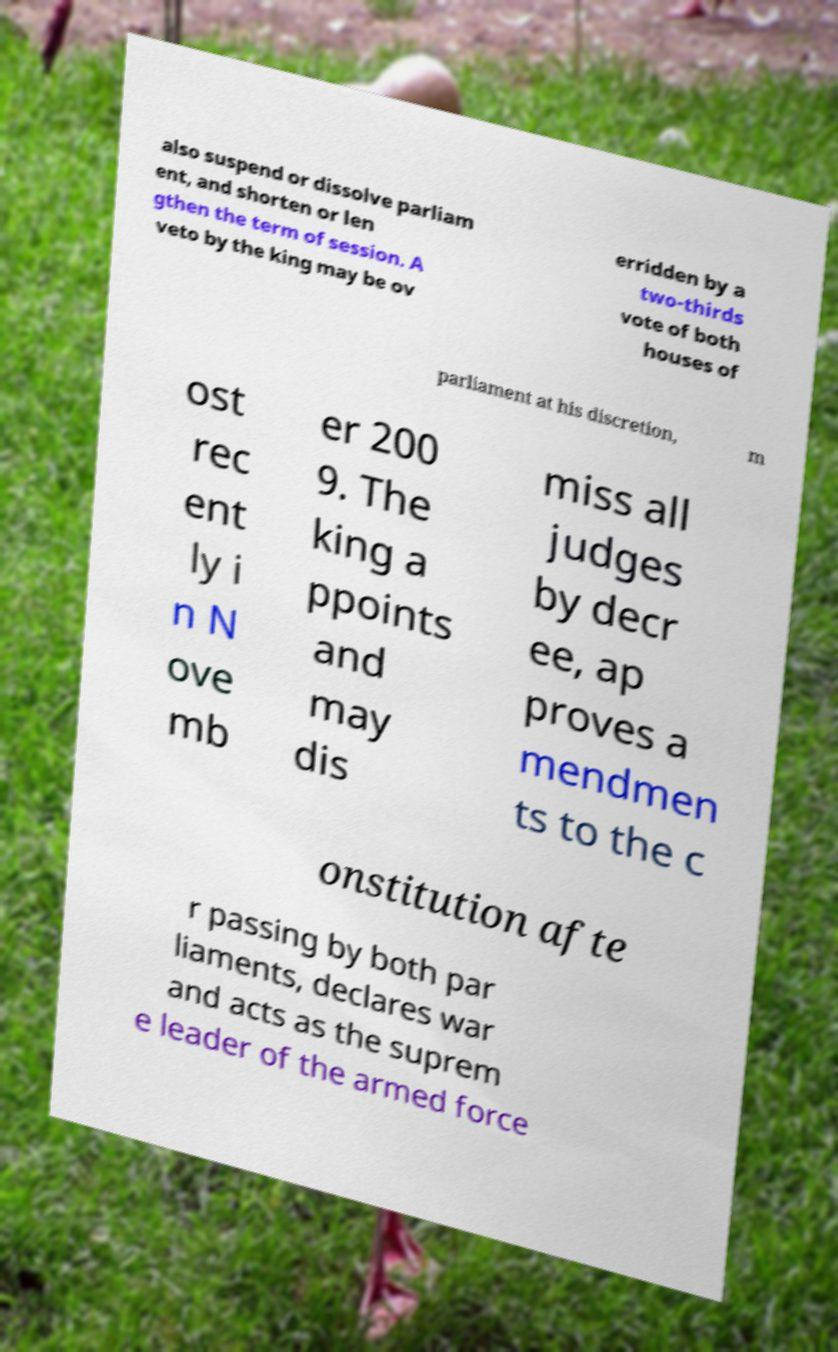Please read and relay the text visible in this image. What does it say? also suspend or dissolve parliam ent, and shorten or len gthen the term of session. A veto by the king may be ov erridden by a two-thirds vote of both houses of parliament at his discretion, m ost rec ent ly i n N ove mb er 200 9. The king a ppoints and may dis miss all judges by decr ee, ap proves a mendmen ts to the c onstitution afte r passing by both par liaments, declares war and acts as the suprem e leader of the armed force 